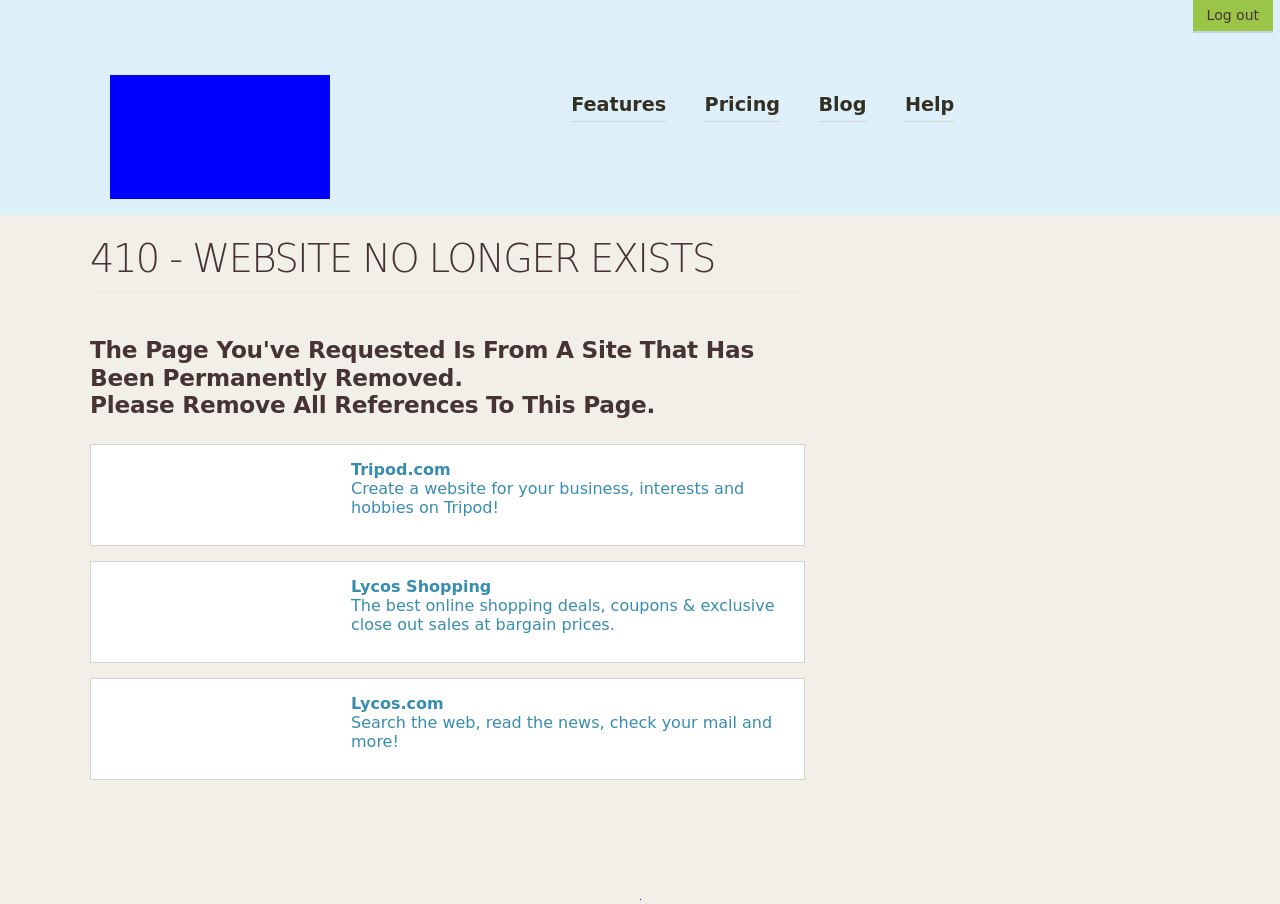How can I start building this website with HTML from the ground up? To start building a website with HTML from scratch, begin by setting up a basic HTML skeleton:
<!DOCTYPE html>
<html lang="en">
<head>
    <meta charset="UTF-8">
    <title>Your Website Title Here</title>
</head>
<body>
    <h1>Welcome to My Website</h1>
    <p>This is a paragraph of text to start off your homepage.</p>
</body>
</html>
This code sets up a basic webpage with a title, a heading, and a paragraph. You can expand your website by adding more HTML elements and applying CSS for styling. This starter template is simple and adaptable for beginners, providing a foundation that you can build upon as you learn more about web development. 